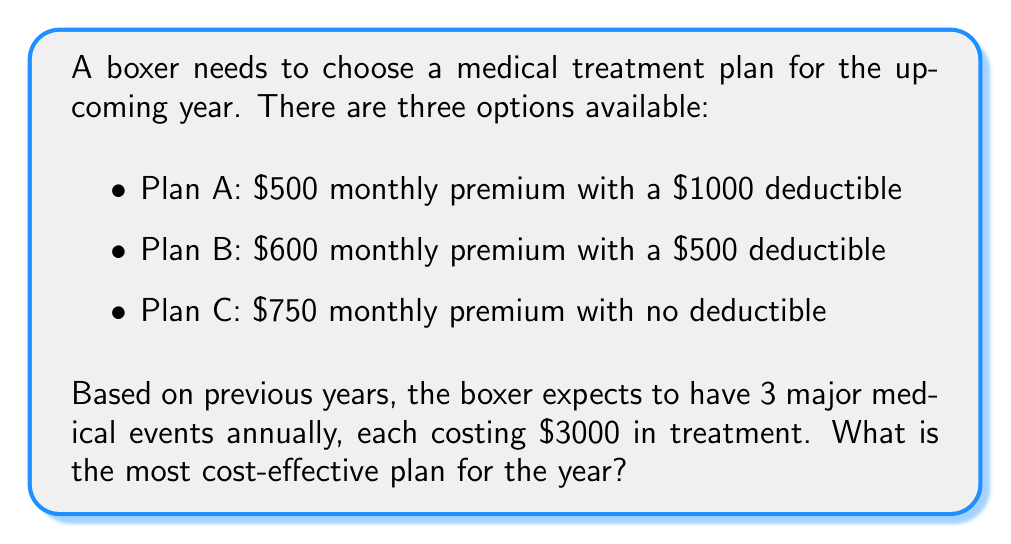Give your solution to this math problem. To determine the most cost-effective plan, we need to calculate the total annual cost for each plan:

1. Calculate the annual premium for each plan:
   Plan A: $500 × 12 = $6000
   Plan B: $600 × 12 = $7200
   Plan C: $750 × 12 = $9000

2. Calculate the out-of-pocket expenses for each plan:
   Plan A: $1000 deductible + 2 × $3000 = $7000
   Plan B: $500 deductible + 2.5 × $3000 = $8000
   Plan C: $0 (no deductible)

3. Calculate the total annual cost for each plan:
   Plan A: $6000 + $7000 = $13,000
   Plan B: $7200 + $8000 = $15,200
   Plan C: $9000 + $0 = $9,000

The calculations can be represented as:

$$\text{Total Annual Cost} = \text{Annual Premium} + \text{Out-of-Pocket Expenses}$$

Where:
$$\text{Annual Premium} = \text{Monthly Premium} \times 12$$
$$\text{Out-of-Pocket Expenses} = \text{Deductible} + (\text{Number of Events} - 1) \times \text{Cost per Event}$$

Plan C has the lowest total annual cost, making it the most cost-effective option for the boxer.
Answer: Plan C, with a total annual cost of $9,000, is the most cost-effective medical treatment plan for the boxer. 